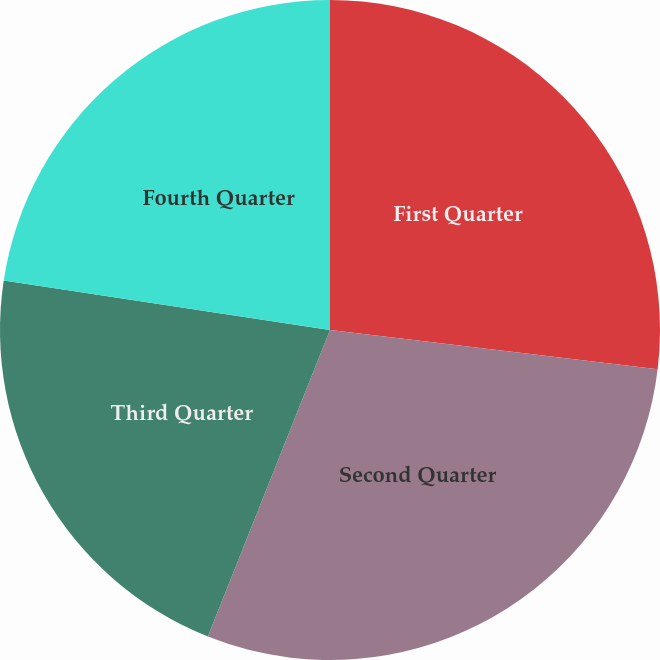<chart> <loc_0><loc_0><loc_500><loc_500><pie_chart><fcel>First Quarter<fcel>Second Quarter<fcel>Third Quarter<fcel>Fourth Quarter<nl><fcel>26.9%<fcel>29.13%<fcel>21.36%<fcel>22.6%<nl></chart> 